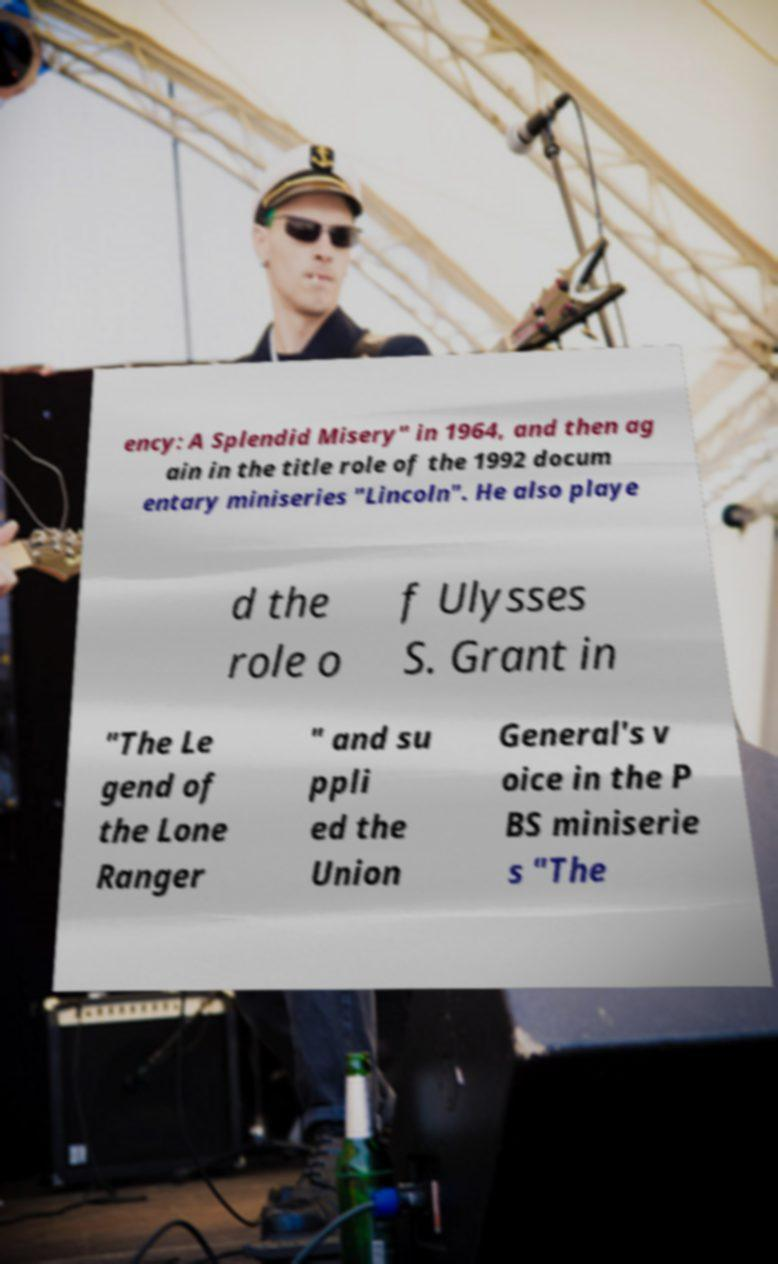Can you read and provide the text displayed in the image?This photo seems to have some interesting text. Can you extract and type it out for me? ency: A Splendid Misery" in 1964, and then ag ain in the title role of the 1992 docum entary miniseries "Lincoln". He also playe d the role o f Ulysses S. Grant in "The Le gend of the Lone Ranger " and su ppli ed the Union General's v oice in the P BS miniserie s "The 